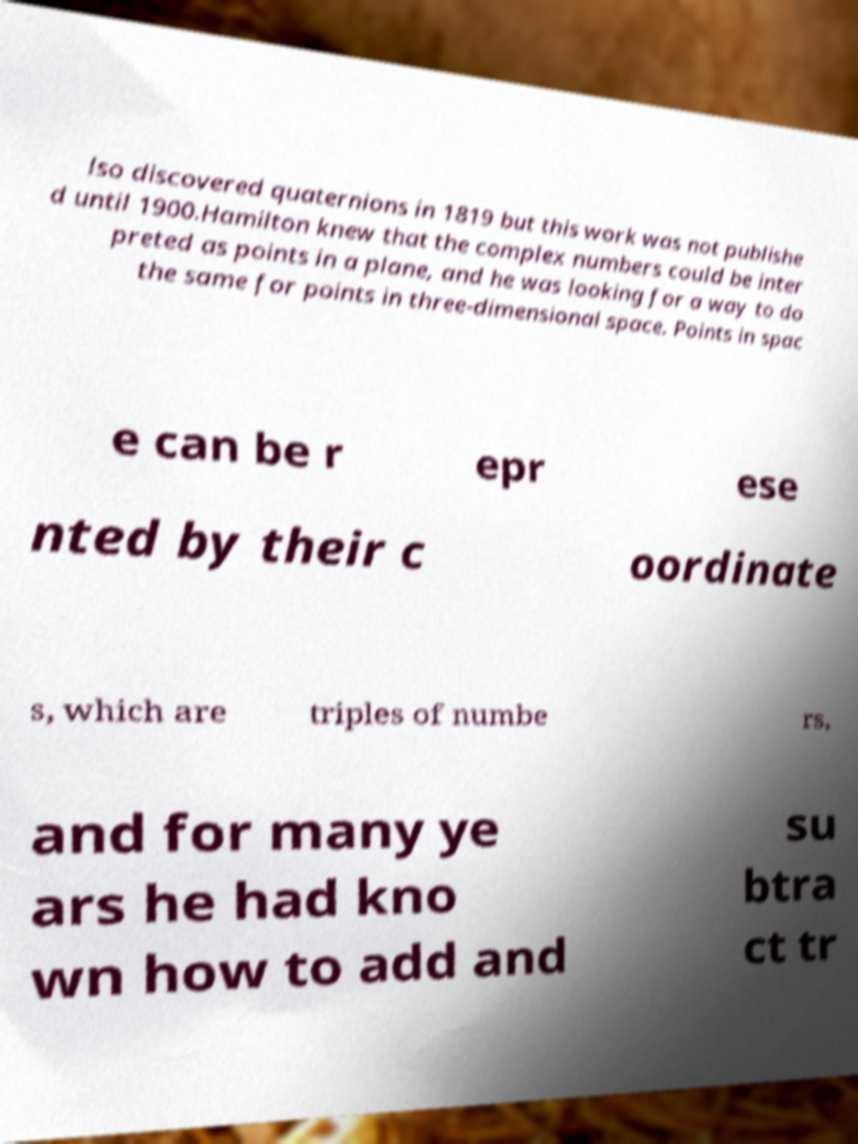There's text embedded in this image that I need extracted. Can you transcribe it verbatim? lso discovered quaternions in 1819 but this work was not publishe d until 1900.Hamilton knew that the complex numbers could be inter preted as points in a plane, and he was looking for a way to do the same for points in three-dimensional space. Points in spac e can be r epr ese nted by their c oordinate s, which are triples of numbe rs, and for many ye ars he had kno wn how to add and su btra ct tr 